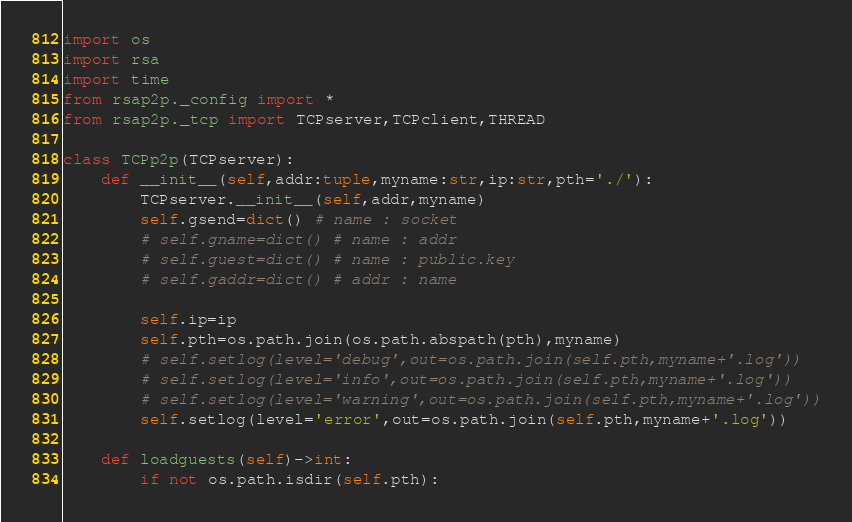Convert code to text. <code><loc_0><loc_0><loc_500><loc_500><_Python_>import os
import rsa
import time
from rsap2p._config import *
from rsap2p._tcp import TCPserver,TCPclient,THREAD

class TCPp2p(TCPserver):
    def __init__(self,addr:tuple,myname:str,ip:str,pth='./'):
        TCPserver.__init__(self,addr,myname)
        self.gsend=dict() # name : socket
        # self.gname=dict() # name : addr
        # self.guest=dict() # name : public.key
        # self.gaddr=dict() # addr : name

        self.ip=ip
        self.pth=os.path.join(os.path.abspath(pth),myname)
        # self.setlog(level='debug',out=os.path.join(self.pth,myname+'.log'))
        # self.setlog(level='info',out=os.path.join(self.pth,myname+'.log'))
        # self.setlog(level='warning',out=os.path.join(self.pth,myname+'.log'))
        self.setlog(level='error',out=os.path.join(self.pth,myname+'.log'))

    def loadguests(self)->int:
        if not os.path.isdir(self.pth):</code> 